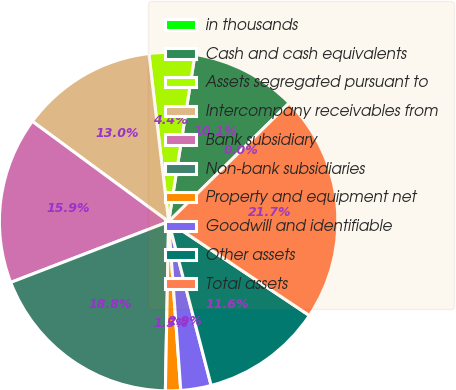Convert chart. <chart><loc_0><loc_0><loc_500><loc_500><pie_chart><fcel>in thousands<fcel>Cash and cash equivalents<fcel>Assets segregated pursuant to<fcel>Intercompany receivables from<fcel>Bank subsidiary<fcel>Non-bank subsidiaries<fcel>Property and equipment net<fcel>Goodwill and identifiable<fcel>Other assets<fcel>Total assets<nl><fcel>0.0%<fcel>10.14%<fcel>4.35%<fcel>13.04%<fcel>15.94%<fcel>18.84%<fcel>1.45%<fcel>2.9%<fcel>11.59%<fcel>21.73%<nl></chart> 